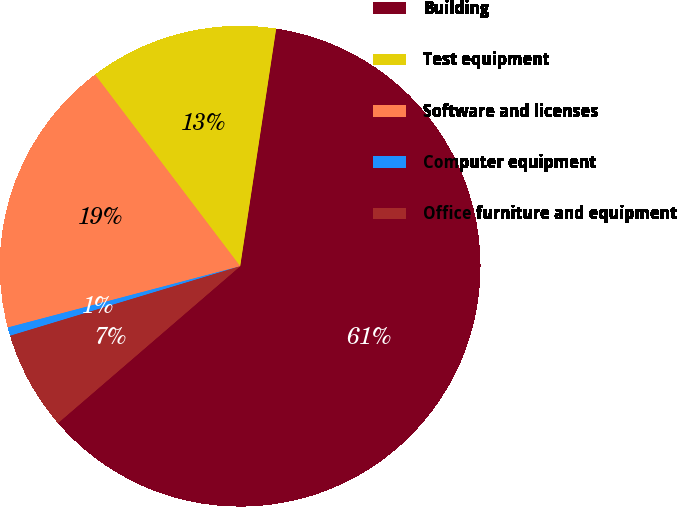<chart> <loc_0><loc_0><loc_500><loc_500><pie_chart><fcel>Building<fcel>Test equipment<fcel>Software and licenses<fcel>Computer equipment<fcel>Office furniture and equipment<nl><fcel>61.3%<fcel>12.71%<fcel>18.79%<fcel>0.57%<fcel>6.64%<nl></chart> 